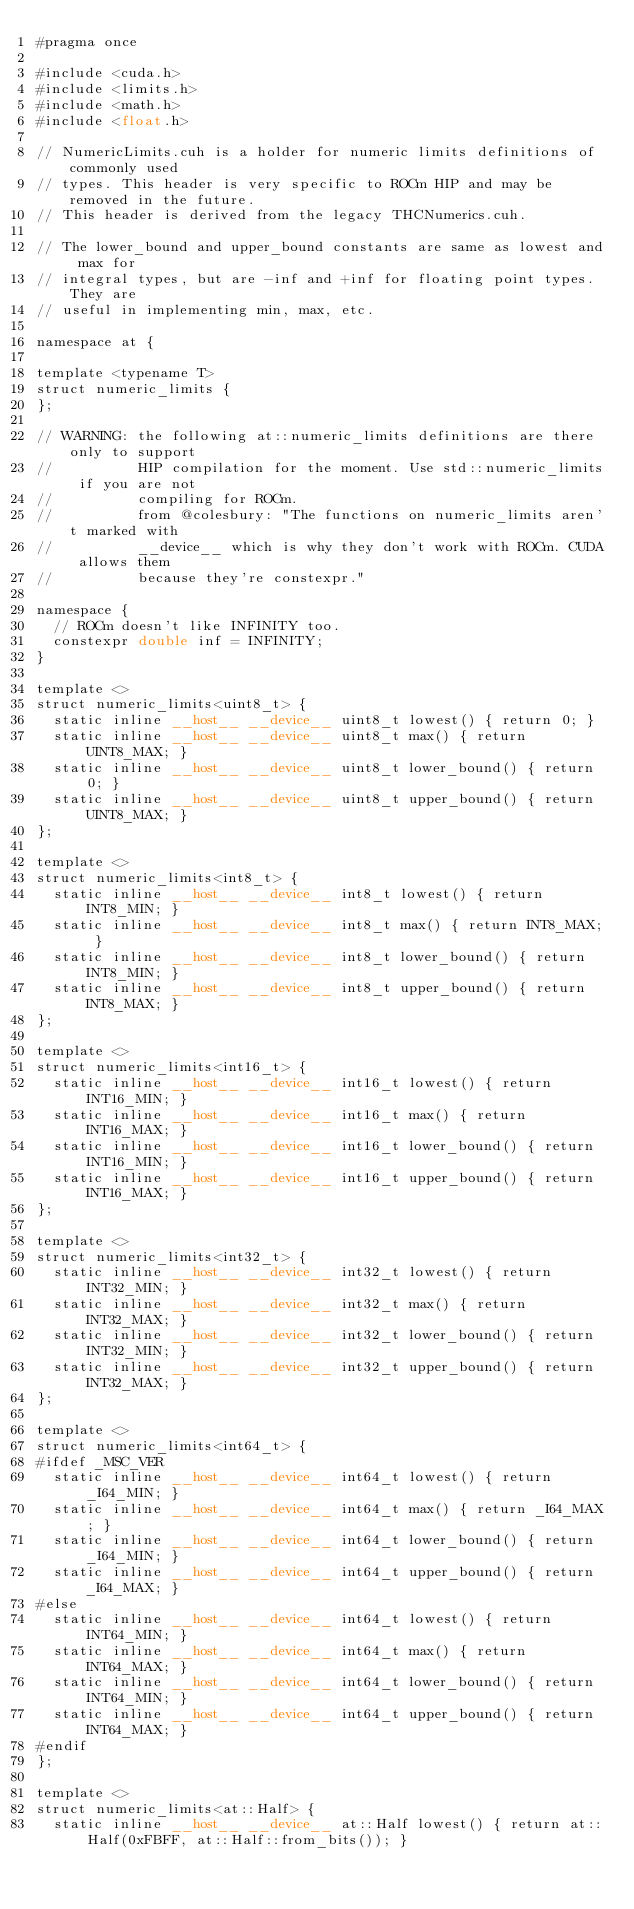Convert code to text. <code><loc_0><loc_0><loc_500><loc_500><_Cuda_>#pragma once

#include <cuda.h>
#include <limits.h>
#include <math.h>
#include <float.h>

// NumericLimits.cuh is a holder for numeric limits definitions of commonly used
// types. This header is very specific to ROCm HIP and may be removed in the future.
// This header is derived from the legacy THCNumerics.cuh.

// The lower_bound and upper_bound constants are same as lowest and max for
// integral types, but are -inf and +inf for floating point types. They are
// useful in implementing min, max, etc.

namespace at {

template <typename T>
struct numeric_limits {
};

// WARNING: the following at::numeric_limits definitions are there only to support
//          HIP compilation for the moment. Use std::numeric_limits if you are not
//          compiling for ROCm.
//          from @colesbury: "The functions on numeric_limits aren't marked with
//          __device__ which is why they don't work with ROCm. CUDA allows them
//          because they're constexpr."

namespace {
  // ROCm doesn't like INFINITY too.
  constexpr double inf = INFINITY;
}

template <>
struct numeric_limits<uint8_t> {
  static inline __host__ __device__ uint8_t lowest() { return 0; }
  static inline __host__ __device__ uint8_t max() { return UINT8_MAX; }
  static inline __host__ __device__ uint8_t lower_bound() { return 0; }
  static inline __host__ __device__ uint8_t upper_bound() { return UINT8_MAX; }
};

template <>
struct numeric_limits<int8_t> {
  static inline __host__ __device__ int8_t lowest() { return INT8_MIN; }
  static inline __host__ __device__ int8_t max() { return INT8_MAX; }
  static inline __host__ __device__ int8_t lower_bound() { return INT8_MIN; }
  static inline __host__ __device__ int8_t upper_bound() { return INT8_MAX; }
};

template <>
struct numeric_limits<int16_t> {
  static inline __host__ __device__ int16_t lowest() { return INT16_MIN; }
  static inline __host__ __device__ int16_t max() { return INT16_MAX; }
  static inline __host__ __device__ int16_t lower_bound() { return INT16_MIN; }
  static inline __host__ __device__ int16_t upper_bound() { return INT16_MAX; }
};

template <>
struct numeric_limits<int32_t> {
  static inline __host__ __device__ int32_t lowest() { return INT32_MIN; }
  static inline __host__ __device__ int32_t max() { return INT32_MAX; }
  static inline __host__ __device__ int32_t lower_bound() { return INT32_MIN; }
  static inline __host__ __device__ int32_t upper_bound() { return INT32_MAX; }
};

template <>
struct numeric_limits<int64_t> {
#ifdef _MSC_VER
  static inline __host__ __device__ int64_t lowest() { return _I64_MIN; }
  static inline __host__ __device__ int64_t max() { return _I64_MAX; }
  static inline __host__ __device__ int64_t lower_bound() { return _I64_MIN; }
  static inline __host__ __device__ int64_t upper_bound() { return _I64_MAX; }
#else
  static inline __host__ __device__ int64_t lowest() { return INT64_MIN; }
  static inline __host__ __device__ int64_t max() { return INT64_MAX; }
  static inline __host__ __device__ int64_t lower_bound() { return INT64_MIN; }
  static inline __host__ __device__ int64_t upper_bound() { return INT64_MAX; }
#endif
};

template <>
struct numeric_limits<at::Half> {
  static inline __host__ __device__ at::Half lowest() { return at::Half(0xFBFF, at::Half::from_bits()); }</code> 